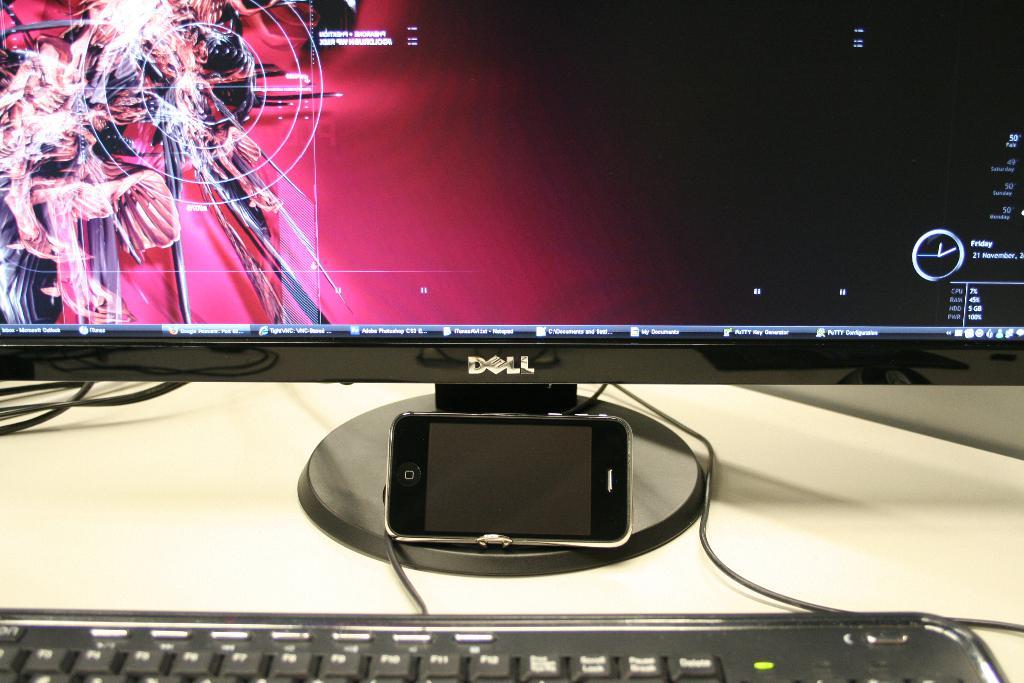What type of machine is that?
Provide a succinct answer. Dell. What day of the week was this picture taken, according to the computer screen?
Your response must be concise. Friday. 